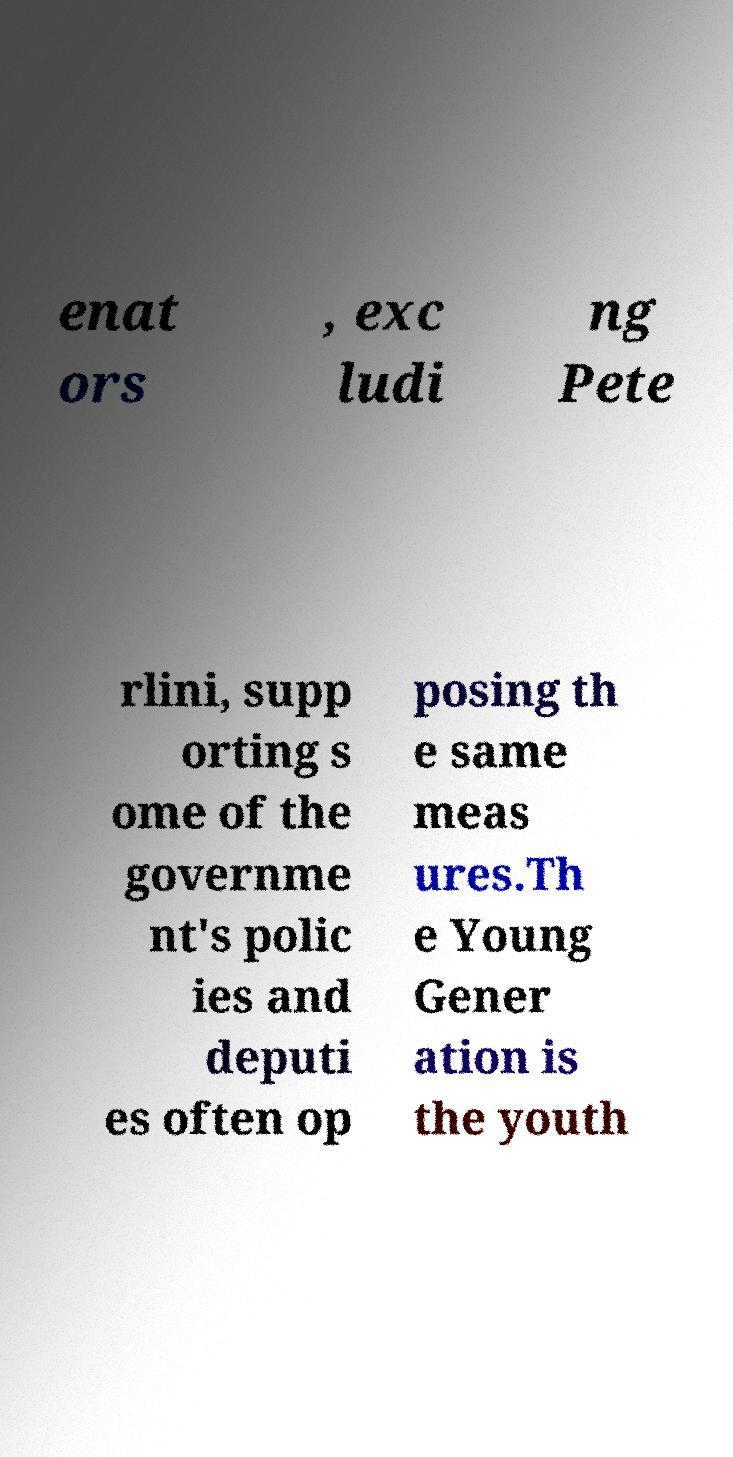I need the written content from this picture converted into text. Can you do that? enat ors , exc ludi ng Pete rlini, supp orting s ome of the governme nt's polic ies and deputi es often op posing th e same meas ures.Th e Young Gener ation is the youth 